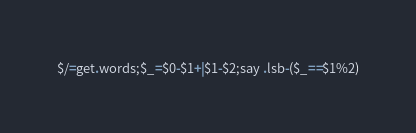Convert code to text. <code><loc_0><loc_0><loc_500><loc_500><_Perl_>$/=get.words;$_=$0-$1+|$1-$2;say .lsb-($_==$1%2)</code> 